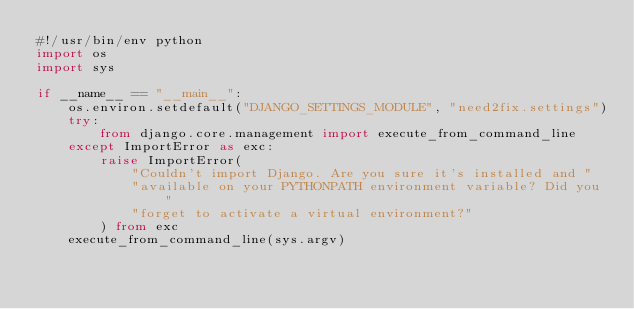<code> <loc_0><loc_0><loc_500><loc_500><_Python_>#!/usr/bin/env python
import os
import sys

if __name__ == "__main__":
    os.environ.setdefault("DJANGO_SETTINGS_MODULE", "need2fix.settings")
    try:
        from django.core.management import execute_from_command_line
    except ImportError as exc:
        raise ImportError(
            "Couldn't import Django. Are you sure it's installed and "
            "available on your PYTHONPATH environment variable? Did you "
            "forget to activate a virtual environment?"
        ) from exc
    execute_from_command_line(sys.argv)
</code> 